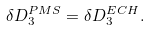<formula> <loc_0><loc_0><loc_500><loc_500>\delta D _ { 3 } ^ { P M S } = \delta D _ { 3 } ^ { E C H } .</formula> 